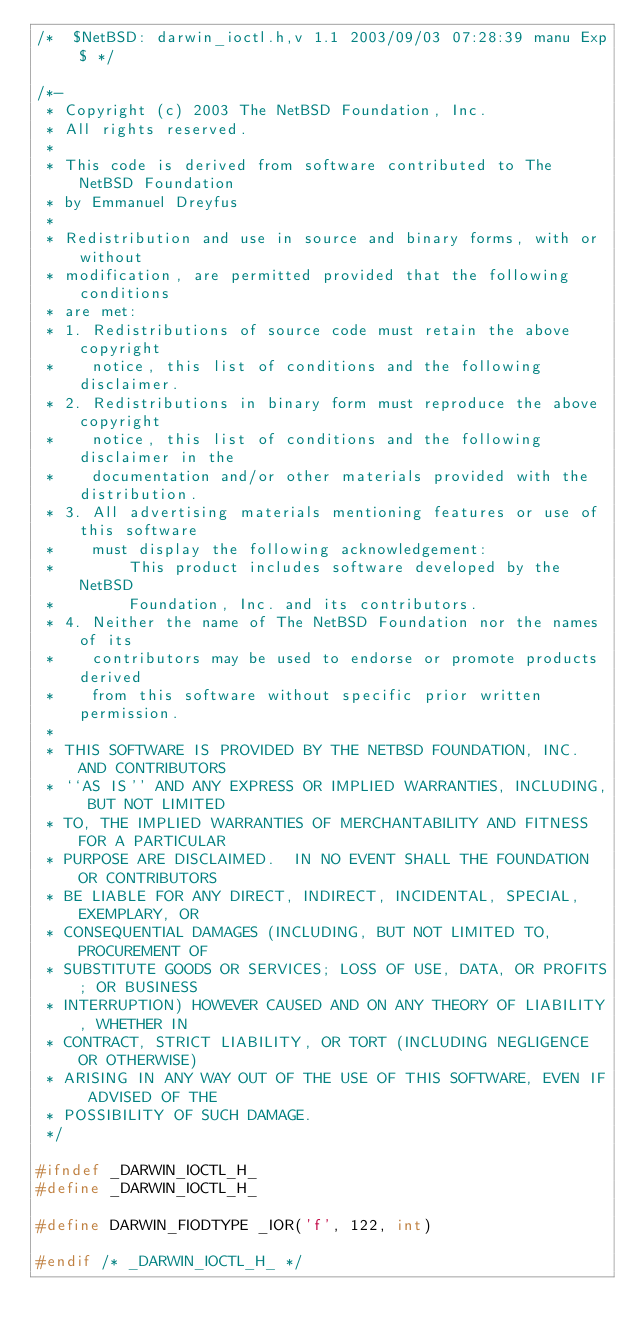Convert code to text. <code><loc_0><loc_0><loc_500><loc_500><_C_>/*	$NetBSD: darwin_ioctl.h,v 1.1 2003/09/03 07:28:39 manu Exp $ */

/*-
 * Copyright (c) 2003 The NetBSD Foundation, Inc.
 * All rights reserved.
 *
 * This code is derived from software contributed to The NetBSD Foundation
 * by Emmanuel Dreyfus
 *
 * Redistribution and use in source and binary forms, with or without
 * modification, are permitted provided that the following conditions
 * are met:
 * 1. Redistributions of source code must retain the above copyright
 *    notice, this list of conditions and the following disclaimer.
 * 2. Redistributions in binary form must reproduce the above copyright
 *    notice, this list of conditions and the following disclaimer in the
 *    documentation and/or other materials provided with the distribution.
 * 3. All advertising materials mentioning features or use of this software
 *    must display the following acknowledgement:
 *        This product includes software developed by the NetBSD
 *        Foundation, Inc. and its contributors.
 * 4. Neither the name of The NetBSD Foundation nor the names of its
 *    contributors may be used to endorse or promote products derived
 *    from this software without specific prior written permission.
 *
 * THIS SOFTWARE IS PROVIDED BY THE NETBSD FOUNDATION, INC. AND CONTRIBUTORS
 * ``AS IS'' AND ANY EXPRESS OR IMPLIED WARRANTIES, INCLUDING, BUT NOT LIMITED
 * TO, THE IMPLIED WARRANTIES OF MERCHANTABILITY AND FITNESS FOR A PARTICULAR
 * PURPOSE ARE DISCLAIMED.  IN NO EVENT SHALL THE FOUNDATION OR CONTRIBUTORS
 * BE LIABLE FOR ANY DIRECT, INDIRECT, INCIDENTAL, SPECIAL, EXEMPLARY, OR
 * CONSEQUENTIAL DAMAGES (INCLUDING, BUT NOT LIMITED TO, PROCUREMENT OF
 * SUBSTITUTE GOODS OR SERVICES; LOSS OF USE, DATA, OR PROFITS; OR BUSINESS
 * INTERRUPTION) HOWEVER CAUSED AND ON ANY THEORY OF LIABILITY, WHETHER IN
 * CONTRACT, STRICT LIABILITY, OR TORT (INCLUDING NEGLIGENCE OR OTHERWISE)
 * ARISING IN ANY WAY OUT OF THE USE OF THIS SOFTWARE, EVEN IF ADVISED OF THE
 * POSSIBILITY OF SUCH DAMAGE.
 */

#ifndef	_DARWIN_IOCTL_H_
#define	_DARWIN_IOCTL_H_

#define DARWIN_FIODTYPE _IOR('f', 122, int)

#endif /* _DARWIN_IOCTL_H_ */
</code> 